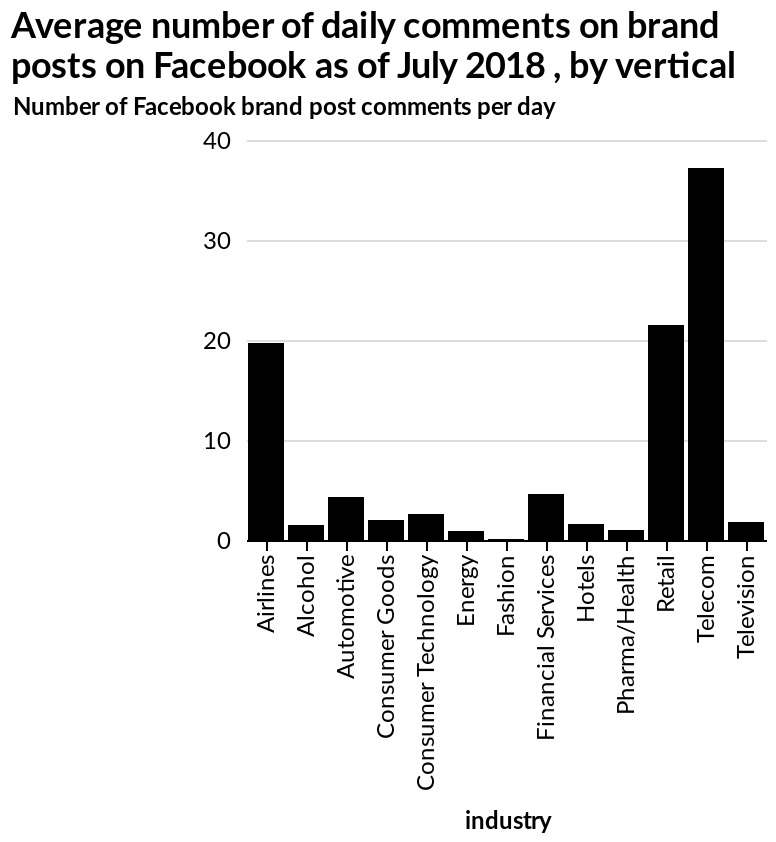<image>
Among various industries, which ones have the highest number of Facebook comments? Among various industries, retail, telecom, and airlines have the highest number of Facebook comments.  What is the unit of measurement for the y-axis on the bar chart? The unit of measurement for the y-axis on the bar chart is the number of Facebook brand post comments per day. 